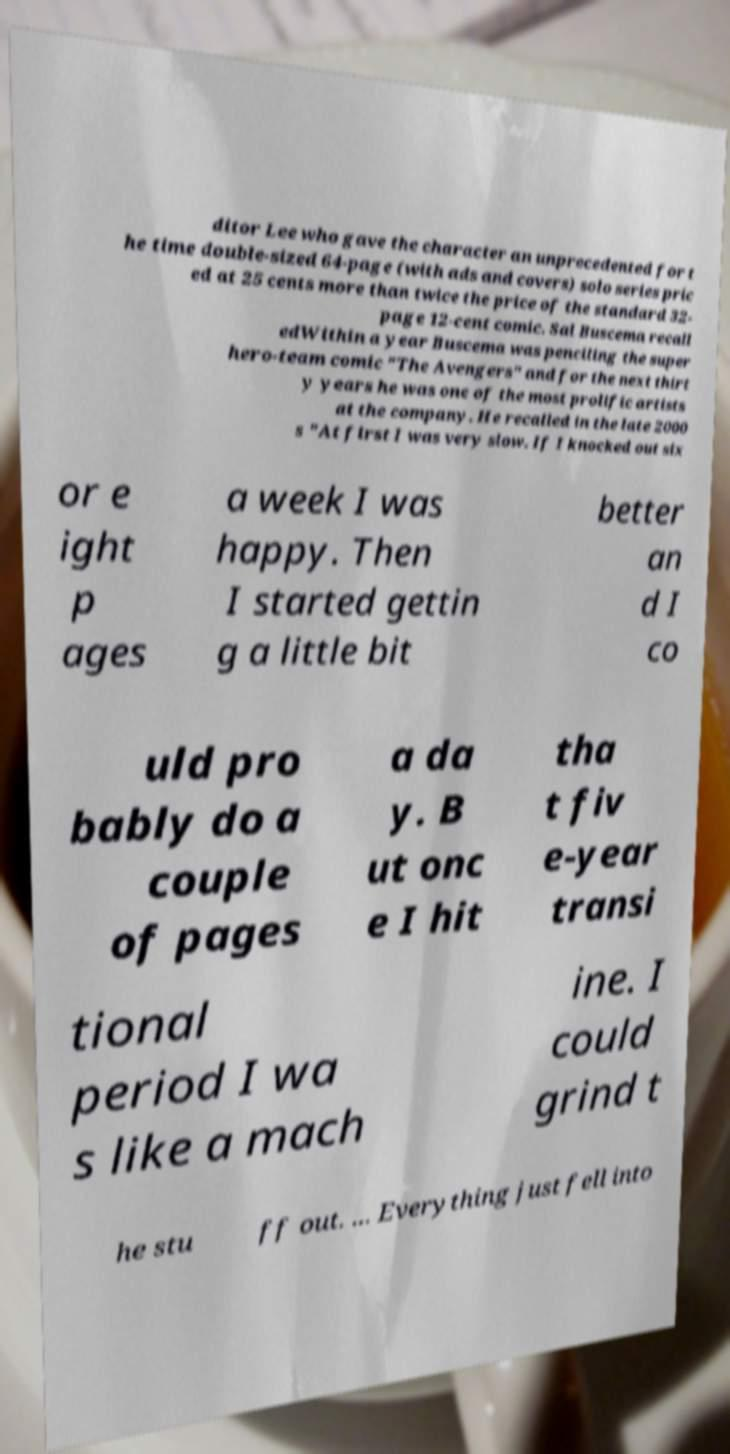Can you read and provide the text displayed in the image?This photo seems to have some interesting text. Can you extract and type it out for me? ditor Lee who gave the character an unprecedented for t he time double-sized 64-page (with ads and covers) solo series pric ed at 25 cents more than twice the price of the standard 32- page 12-cent comic. Sal Buscema recall edWithin a year Buscema was penciling the super hero-team comic "The Avengers" and for the next thirt y years he was one of the most prolific artists at the company. He recalled in the late 2000 s "At first I was very slow. If I knocked out six or e ight p ages a week I was happy. Then I started gettin g a little bit better an d I co uld pro bably do a couple of pages a da y. B ut onc e I hit tha t fiv e-year transi tional period I wa s like a mach ine. I could grind t he stu ff out. ... Everything just fell into 